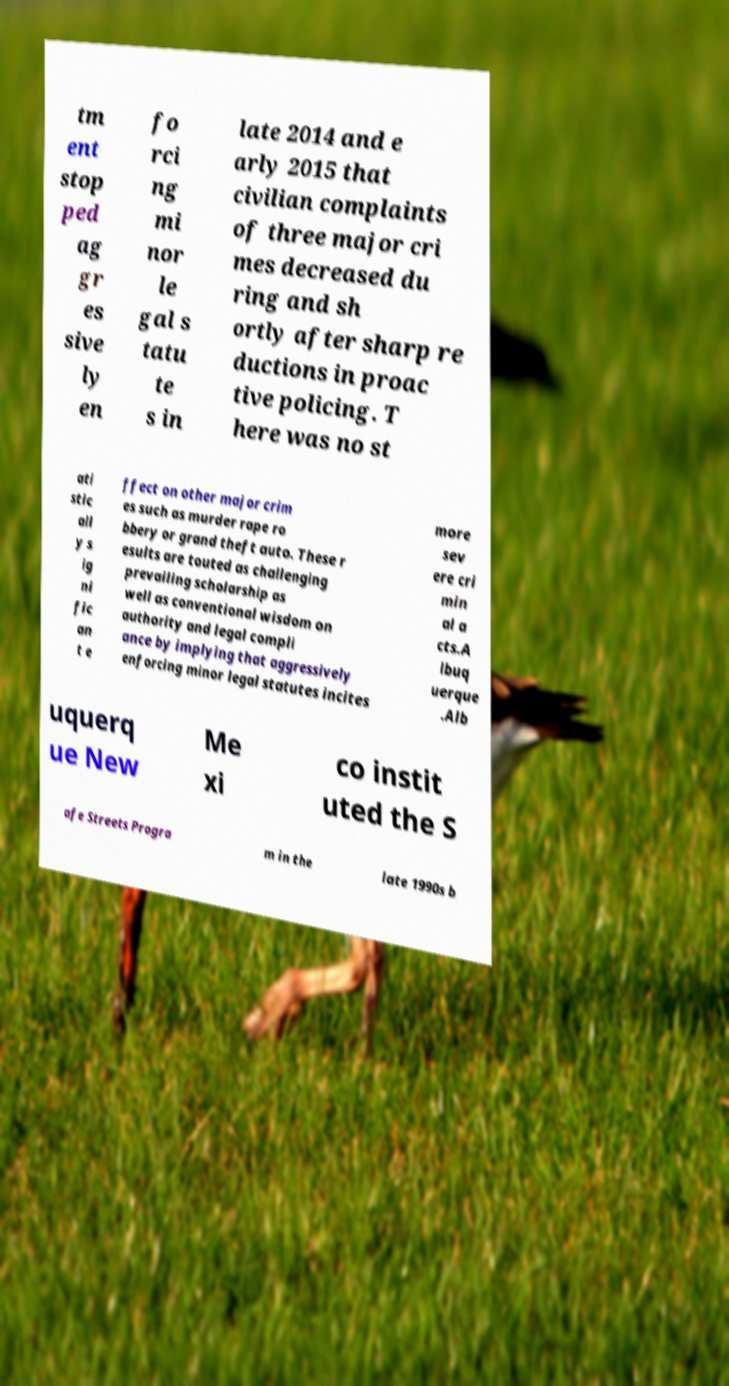Could you extract and type out the text from this image? tm ent stop ped ag gr es sive ly en fo rci ng mi nor le gal s tatu te s in late 2014 and e arly 2015 that civilian complaints of three major cri mes decreased du ring and sh ortly after sharp re ductions in proac tive policing. T here was no st ati stic all y s ig ni fic an t e ffect on other major crim es such as murder rape ro bbery or grand theft auto. These r esults are touted as challenging prevailing scholarship as well as conventional wisdom on authority and legal compli ance by implying that aggressively enforcing minor legal statutes incites more sev ere cri min al a cts.A lbuq uerque .Alb uquerq ue New Me xi co instit uted the S afe Streets Progra m in the late 1990s b 